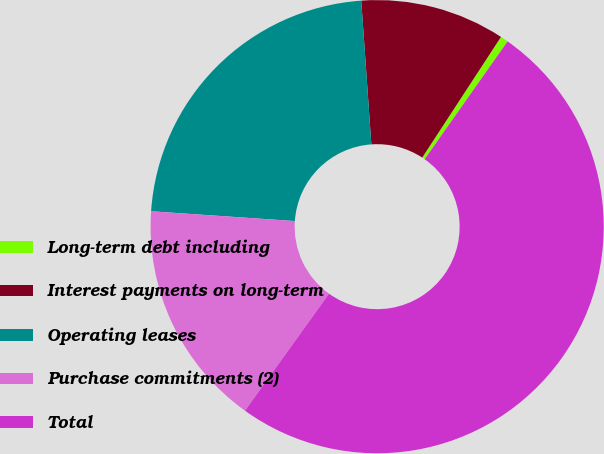Convert chart to OTSL. <chart><loc_0><loc_0><loc_500><loc_500><pie_chart><fcel>Long-term debt including<fcel>Interest payments on long-term<fcel>Operating leases<fcel>Purchase commitments (2)<fcel>Total<nl><fcel>0.56%<fcel>10.32%<fcel>22.8%<fcel>16.17%<fcel>50.15%<nl></chart> 